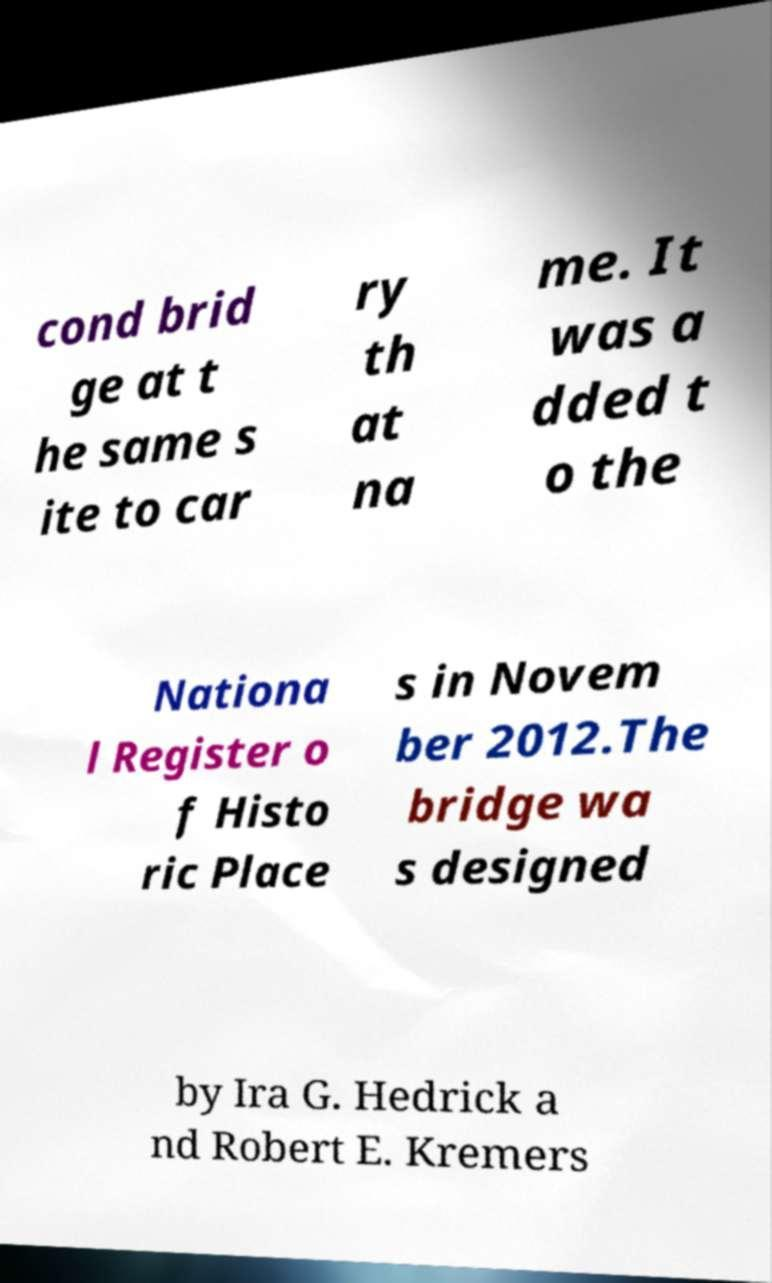What messages or text are displayed in this image? I need them in a readable, typed format. cond brid ge at t he same s ite to car ry th at na me. It was a dded t o the Nationa l Register o f Histo ric Place s in Novem ber 2012.The bridge wa s designed by Ira G. Hedrick a nd Robert E. Kremers 